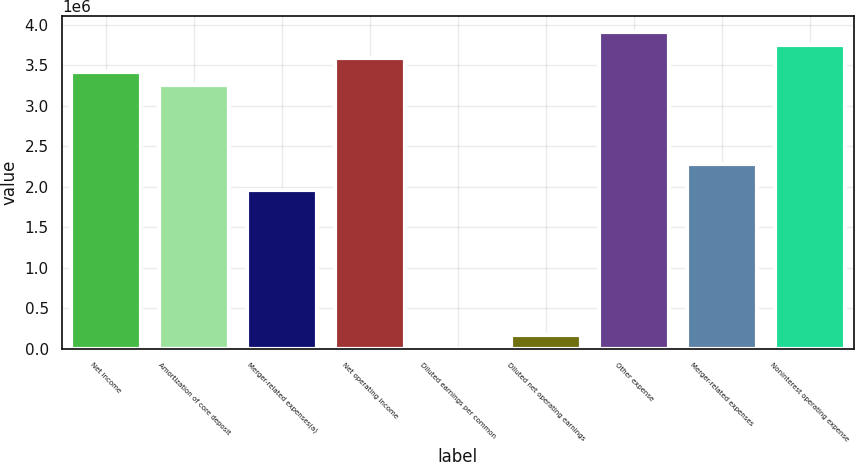Convert chart to OTSL. <chart><loc_0><loc_0><loc_500><loc_500><bar_chart><fcel>Net income<fcel>Amortization of core deposit<fcel>Merger-related expenses(a)<fcel>Net operating income<fcel>Diluted earnings per common<fcel>Diluted net operating earnings<fcel>Other expense<fcel>Merger-related expenses<fcel>Noninterest operating expense<nl><fcel>3.41814e+06<fcel>3.25537e+06<fcel>1.95323e+06<fcel>3.58091e+06<fcel>5.95<fcel>162774<fcel>3.90645e+06<fcel>2.27876e+06<fcel>3.74368e+06<nl></chart> 